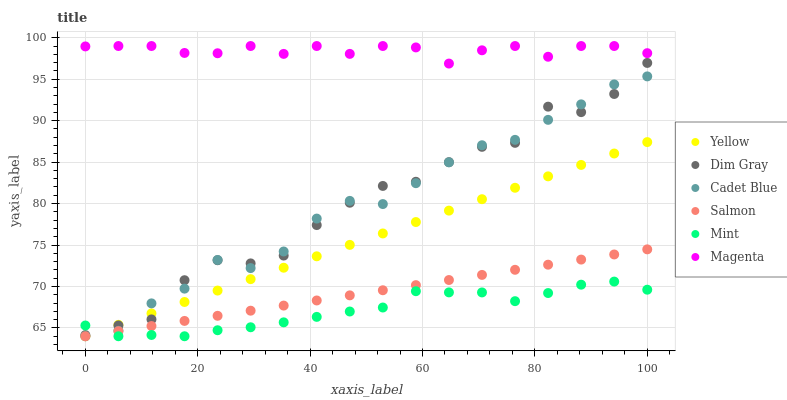Does Mint have the minimum area under the curve?
Answer yes or no. Yes. Does Magenta have the maximum area under the curve?
Answer yes or no. Yes. Does Salmon have the minimum area under the curve?
Answer yes or no. No. Does Salmon have the maximum area under the curve?
Answer yes or no. No. Is Yellow the smoothest?
Answer yes or no. Yes. Is Dim Gray the roughest?
Answer yes or no. Yes. Is Salmon the smoothest?
Answer yes or no. No. Is Salmon the roughest?
Answer yes or no. No. Does Cadet Blue have the lowest value?
Answer yes or no. Yes. Does Dim Gray have the lowest value?
Answer yes or no. No. Does Magenta have the highest value?
Answer yes or no. Yes. Does Salmon have the highest value?
Answer yes or no. No. Is Yellow less than Magenta?
Answer yes or no. Yes. Is Magenta greater than Dim Gray?
Answer yes or no. Yes. Does Dim Gray intersect Yellow?
Answer yes or no. Yes. Is Dim Gray less than Yellow?
Answer yes or no. No. Is Dim Gray greater than Yellow?
Answer yes or no. No. Does Yellow intersect Magenta?
Answer yes or no. No. 